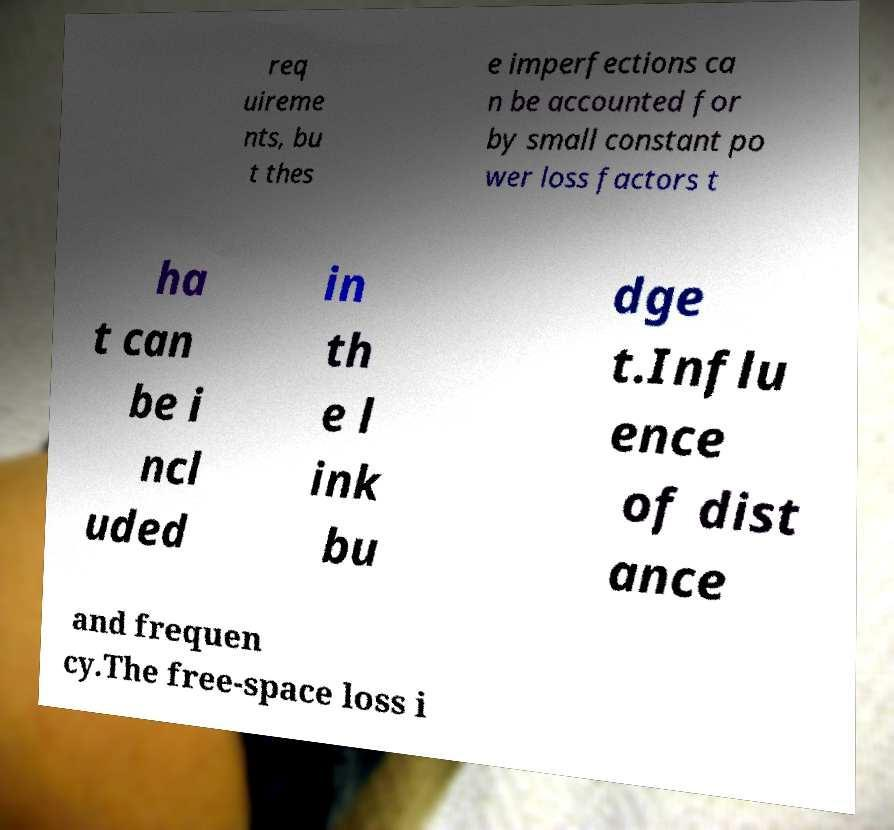Can you accurately transcribe the text from the provided image for me? req uireme nts, bu t thes e imperfections ca n be accounted for by small constant po wer loss factors t ha t can be i ncl uded in th e l ink bu dge t.Influ ence of dist ance and frequen cy.The free-space loss i 